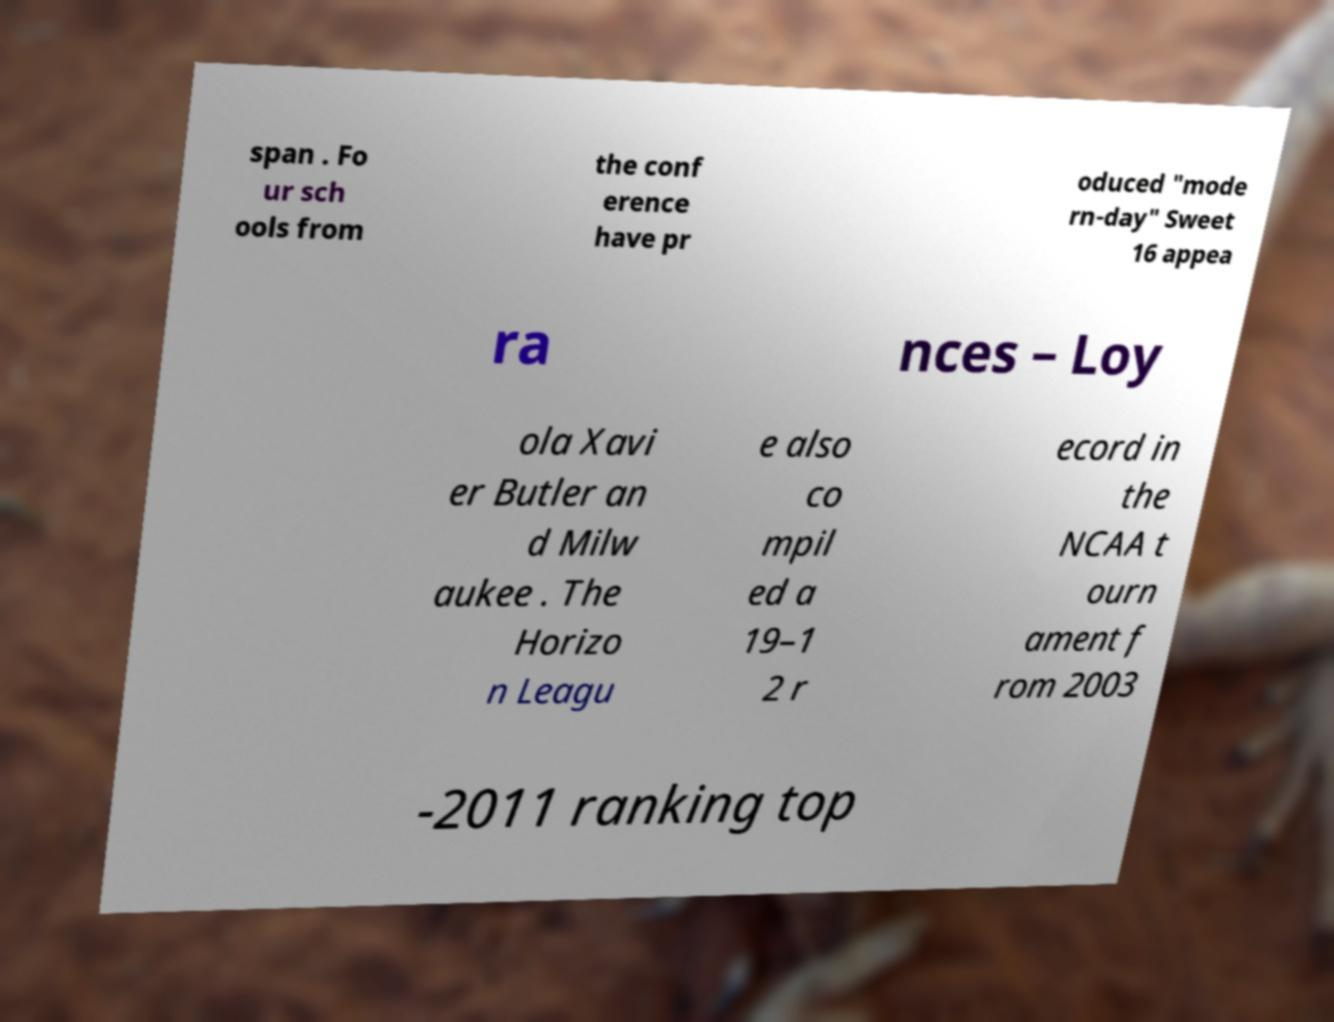For documentation purposes, I need the text within this image transcribed. Could you provide that? span . Fo ur sch ools from the conf erence have pr oduced "mode rn-day" Sweet 16 appea ra nces – Loy ola Xavi er Butler an d Milw aukee . The Horizo n Leagu e also co mpil ed a 19–1 2 r ecord in the NCAA t ourn ament f rom 2003 -2011 ranking top 